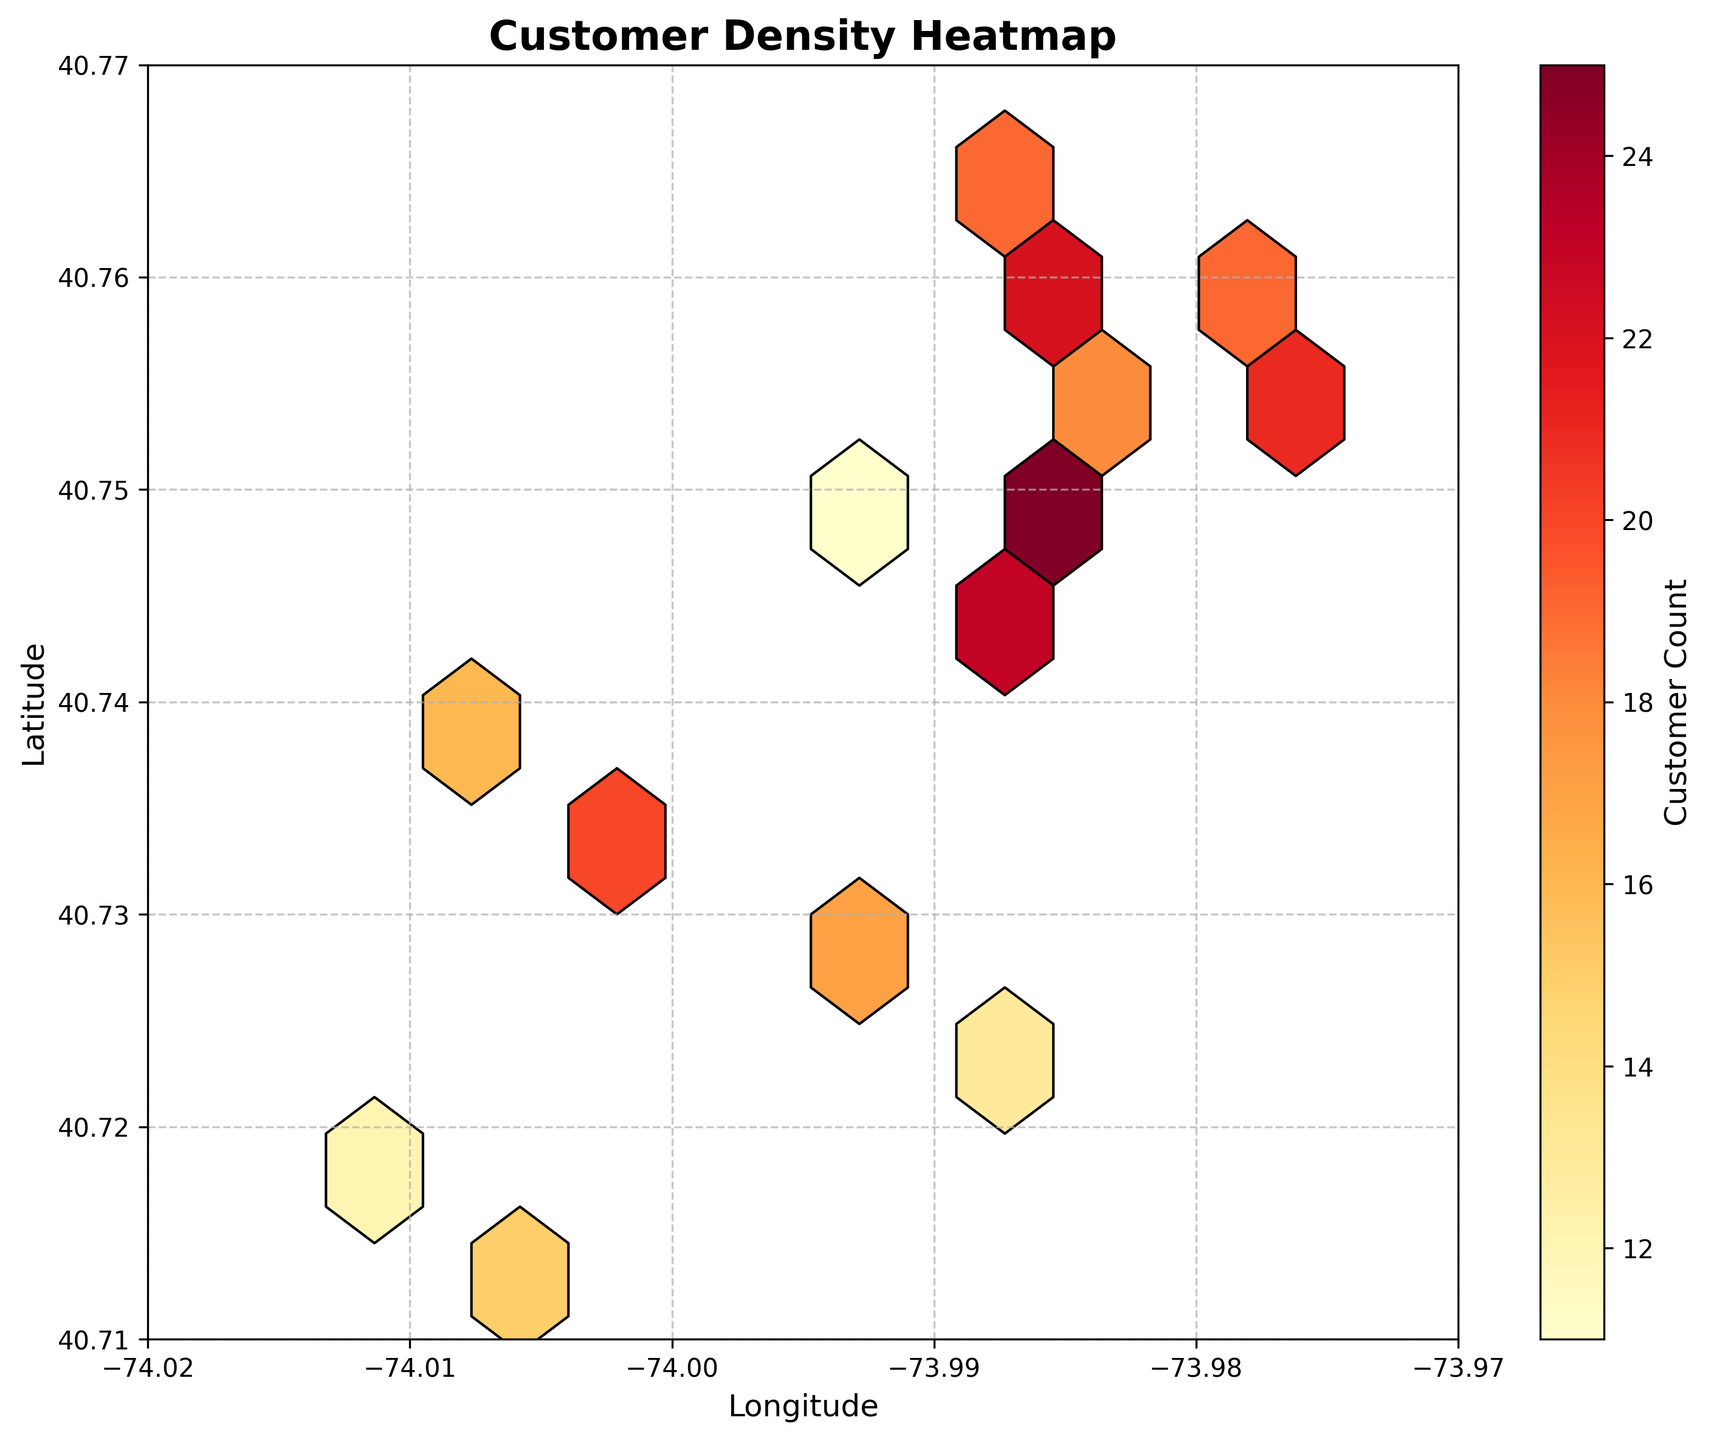What is the title of the figure? The title is displayed at the top of the figure and provides a summary of what the figure is about.
Answer: Customer Density Heatmap What do the axes represent? The axes indicate the geographical coordinates of customer home addresses: the x-axis represents longitude, and the y-axis represents latitude.
Answer: Longitude (x-axis) and Latitude (y-axis) What does the color intensity represent in this plot? The color intensity in the hexbin plot represents the customer count; darker colors indicate a higher number of customers.
Answer: Customer count What is the range of longitudes plotted on the x-axis? Observing the x-axis limits, which set the boundaries for the data on the horizontal axis.
Answer: -74.02 to -73.97 What is the grid size used for hexagonal bins? The size of each hexagonal bin can generally be understood from the context or by default settings which is 10 in this context.
Answer: 10 Which region has the highest customer density? Identify regions with the darkest hexagons as they represent the highest customer count.
Answer: Near latitude 40.748 and longitude -73.985 Is there any area with a significantly lower customer density? Look for areas with the lightest hexagons which indicate fewer customers.
Answer: Near latitude 40.718 and longitude -74.013 What is the average customer count in the densest regions? Visually estimate from the color code or observe the color bar that maps colors to customer counts.
Answer: Approximately 25 How does the customer density distribution change from west to east? Compare the hexagon color intensity from the left (west) side of the plot to the right (east) side.
Answer: Higher density in the center, decreases towards the edges What does the color bar on the right side of the plot represent? The color bar assists in interpreting the color intensity in hexagons corresponding to customer count values.
Answer: Customer count 